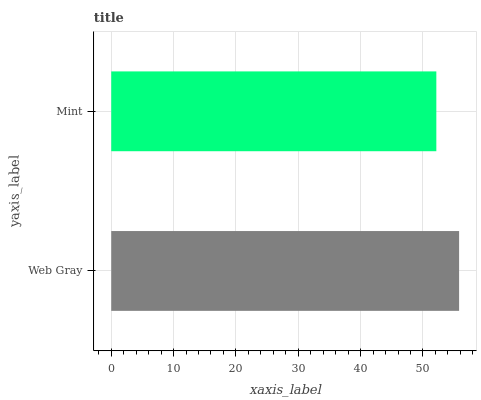Is Mint the minimum?
Answer yes or no. Yes. Is Web Gray the maximum?
Answer yes or no. Yes. Is Mint the maximum?
Answer yes or no. No. Is Web Gray greater than Mint?
Answer yes or no. Yes. Is Mint less than Web Gray?
Answer yes or no. Yes. Is Mint greater than Web Gray?
Answer yes or no. No. Is Web Gray less than Mint?
Answer yes or no. No. Is Web Gray the high median?
Answer yes or no. Yes. Is Mint the low median?
Answer yes or no. Yes. Is Mint the high median?
Answer yes or no. No. Is Web Gray the low median?
Answer yes or no. No. 